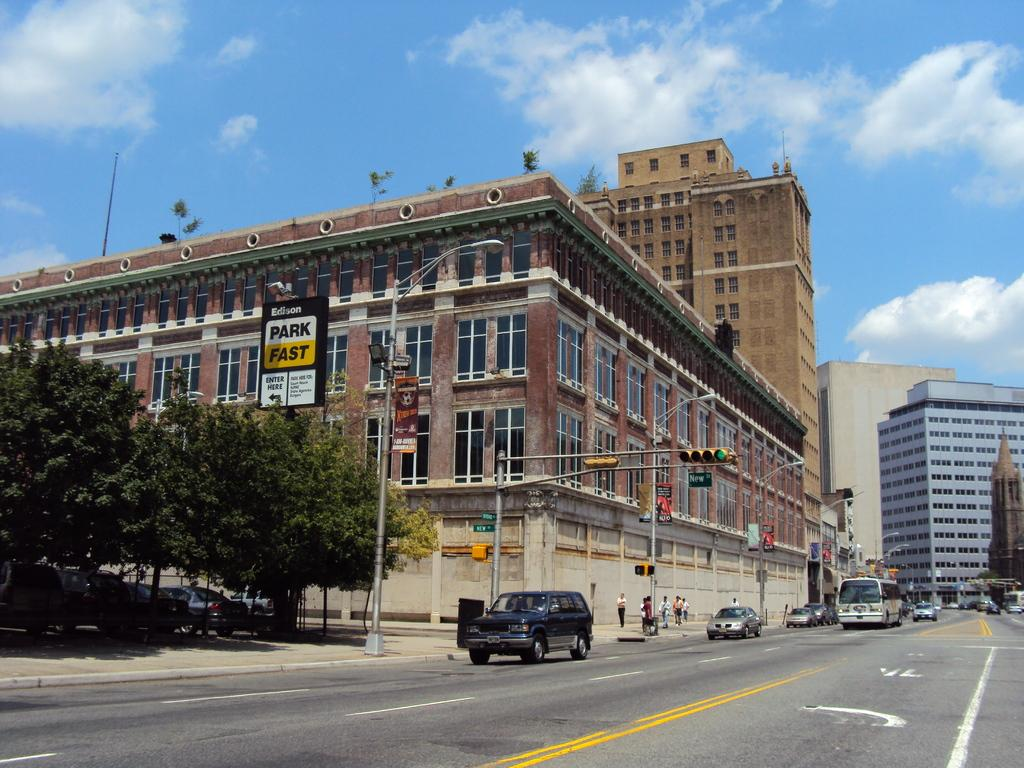What type of structures can be seen in the image? There are buildings in the image. What other natural elements are present in the image? There are trees in the image. Are there any people visible in the image? Yes, there are people in the image. What type of lighting is present in the image? Street lamps are visible in the image. What mode of transportation can be seen in the image? There is a bus in the image. Are there any other vehicles present in the image? Yes, there are cars in the image. What can be seen in the sky in the image? The sky is visible in the image, and clouds are present in the sky. What type of shirt is the fang wearing on the stage in the image? There is no shirt, fang, or stage present in the image. 